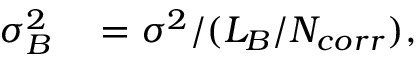<formula> <loc_0><loc_0><loc_500><loc_500>\begin{array} { r l } { \sigma _ { B } ^ { 2 } } & = \sigma ^ { 2 } / ( L _ { B } / N _ { c o r r } ) , } \end{array}</formula> 